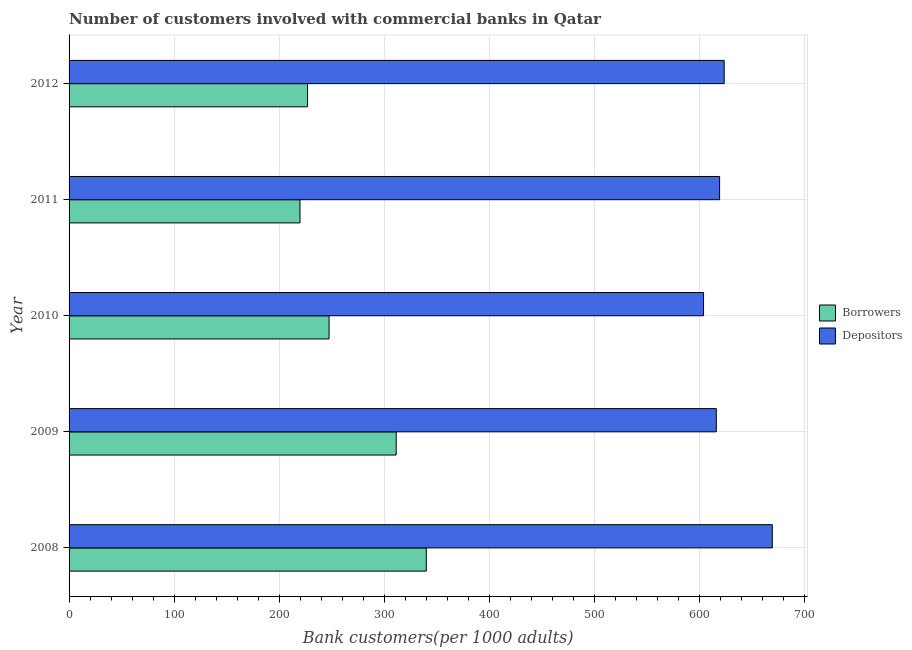Are the number of bars on each tick of the Y-axis equal?
Offer a terse response. Yes. What is the label of the 4th group of bars from the top?
Ensure brevity in your answer.  2009. What is the number of borrowers in 2009?
Ensure brevity in your answer.  311.18. Across all years, what is the maximum number of borrowers?
Your answer should be compact. 339.83. Across all years, what is the minimum number of borrowers?
Your response must be concise. 219.67. In which year was the number of borrowers maximum?
Provide a short and direct response. 2008. What is the total number of borrowers in the graph?
Ensure brevity in your answer.  1344.89. What is the difference between the number of borrowers in 2008 and that in 2012?
Offer a very short reply. 112.96. What is the difference between the number of borrowers in 2012 and the number of depositors in 2008?
Keep it short and to the point. -442.12. What is the average number of borrowers per year?
Offer a terse response. 268.98. In the year 2011, what is the difference between the number of borrowers and number of depositors?
Offer a very short reply. -399.17. In how many years, is the number of borrowers greater than 680 ?
Your answer should be compact. 0. What is the ratio of the number of borrowers in 2008 to that in 2012?
Give a very brief answer. 1.5. Is the number of depositors in 2010 less than that in 2011?
Provide a succinct answer. Yes. What is the difference between the highest and the second highest number of depositors?
Your response must be concise. 45.77. What is the difference between the highest and the lowest number of depositors?
Your answer should be very brief. 65.42. Is the sum of the number of borrowers in 2008 and 2011 greater than the maximum number of depositors across all years?
Keep it short and to the point. No. What does the 2nd bar from the top in 2010 represents?
Keep it short and to the point. Borrowers. What does the 1st bar from the bottom in 2011 represents?
Provide a short and direct response. Borrowers. How many bars are there?
Provide a short and direct response. 10. Are all the bars in the graph horizontal?
Your answer should be very brief. Yes. How many years are there in the graph?
Offer a terse response. 5. What is the difference between two consecutive major ticks on the X-axis?
Provide a short and direct response. 100. Are the values on the major ticks of X-axis written in scientific E-notation?
Your answer should be compact. No. Does the graph contain grids?
Your answer should be very brief. Yes. What is the title of the graph?
Offer a terse response. Number of customers involved with commercial banks in Qatar. Does "RDB nonconcessional" appear as one of the legend labels in the graph?
Provide a short and direct response. No. What is the label or title of the X-axis?
Your response must be concise. Bank customers(per 1000 adults). What is the Bank customers(per 1000 adults) in Borrowers in 2008?
Your response must be concise. 339.83. What is the Bank customers(per 1000 adults) of Depositors in 2008?
Ensure brevity in your answer.  668.99. What is the Bank customers(per 1000 adults) in Borrowers in 2009?
Your response must be concise. 311.18. What is the Bank customers(per 1000 adults) in Depositors in 2009?
Give a very brief answer. 615.73. What is the Bank customers(per 1000 adults) in Borrowers in 2010?
Give a very brief answer. 247.33. What is the Bank customers(per 1000 adults) in Depositors in 2010?
Your response must be concise. 603.57. What is the Bank customers(per 1000 adults) of Borrowers in 2011?
Your answer should be compact. 219.67. What is the Bank customers(per 1000 adults) in Depositors in 2011?
Provide a short and direct response. 618.84. What is the Bank customers(per 1000 adults) of Borrowers in 2012?
Your response must be concise. 226.87. What is the Bank customers(per 1000 adults) in Depositors in 2012?
Keep it short and to the point. 623.22. Across all years, what is the maximum Bank customers(per 1000 adults) of Borrowers?
Offer a very short reply. 339.83. Across all years, what is the maximum Bank customers(per 1000 adults) of Depositors?
Keep it short and to the point. 668.99. Across all years, what is the minimum Bank customers(per 1000 adults) of Borrowers?
Provide a short and direct response. 219.67. Across all years, what is the minimum Bank customers(per 1000 adults) in Depositors?
Make the answer very short. 603.57. What is the total Bank customers(per 1000 adults) in Borrowers in the graph?
Offer a very short reply. 1344.89. What is the total Bank customers(per 1000 adults) in Depositors in the graph?
Your response must be concise. 3130.35. What is the difference between the Bank customers(per 1000 adults) of Borrowers in 2008 and that in 2009?
Give a very brief answer. 28.65. What is the difference between the Bank customers(per 1000 adults) of Depositors in 2008 and that in 2009?
Keep it short and to the point. 53.27. What is the difference between the Bank customers(per 1000 adults) of Borrowers in 2008 and that in 2010?
Your answer should be compact. 92.5. What is the difference between the Bank customers(per 1000 adults) in Depositors in 2008 and that in 2010?
Offer a terse response. 65.42. What is the difference between the Bank customers(per 1000 adults) in Borrowers in 2008 and that in 2011?
Provide a short and direct response. 120.16. What is the difference between the Bank customers(per 1000 adults) of Depositors in 2008 and that in 2011?
Make the answer very short. 50.15. What is the difference between the Bank customers(per 1000 adults) of Borrowers in 2008 and that in 2012?
Offer a terse response. 112.96. What is the difference between the Bank customers(per 1000 adults) in Depositors in 2008 and that in 2012?
Your response must be concise. 45.77. What is the difference between the Bank customers(per 1000 adults) in Borrowers in 2009 and that in 2010?
Provide a short and direct response. 63.85. What is the difference between the Bank customers(per 1000 adults) of Depositors in 2009 and that in 2010?
Your answer should be compact. 12.15. What is the difference between the Bank customers(per 1000 adults) of Borrowers in 2009 and that in 2011?
Make the answer very short. 91.51. What is the difference between the Bank customers(per 1000 adults) in Depositors in 2009 and that in 2011?
Ensure brevity in your answer.  -3.12. What is the difference between the Bank customers(per 1000 adults) in Borrowers in 2009 and that in 2012?
Give a very brief answer. 84.31. What is the difference between the Bank customers(per 1000 adults) in Depositors in 2009 and that in 2012?
Ensure brevity in your answer.  -7.5. What is the difference between the Bank customers(per 1000 adults) of Borrowers in 2010 and that in 2011?
Keep it short and to the point. 27.65. What is the difference between the Bank customers(per 1000 adults) in Depositors in 2010 and that in 2011?
Ensure brevity in your answer.  -15.27. What is the difference between the Bank customers(per 1000 adults) in Borrowers in 2010 and that in 2012?
Your answer should be compact. 20.46. What is the difference between the Bank customers(per 1000 adults) of Depositors in 2010 and that in 2012?
Give a very brief answer. -19.65. What is the difference between the Bank customers(per 1000 adults) in Borrowers in 2011 and that in 2012?
Give a very brief answer. -7.2. What is the difference between the Bank customers(per 1000 adults) of Depositors in 2011 and that in 2012?
Make the answer very short. -4.38. What is the difference between the Bank customers(per 1000 adults) in Borrowers in 2008 and the Bank customers(per 1000 adults) in Depositors in 2009?
Offer a terse response. -275.9. What is the difference between the Bank customers(per 1000 adults) of Borrowers in 2008 and the Bank customers(per 1000 adults) of Depositors in 2010?
Offer a terse response. -263.74. What is the difference between the Bank customers(per 1000 adults) of Borrowers in 2008 and the Bank customers(per 1000 adults) of Depositors in 2011?
Your answer should be compact. -279.01. What is the difference between the Bank customers(per 1000 adults) in Borrowers in 2008 and the Bank customers(per 1000 adults) in Depositors in 2012?
Provide a succinct answer. -283.39. What is the difference between the Bank customers(per 1000 adults) of Borrowers in 2009 and the Bank customers(per 1000 adults) of Depositors in 2010?
Ensure brevity in your answer.  -292.39. What is the difference between the Bank customers(per 1000 adults) of Borrowers in 2009 and the Bank customers(per 1000 adults) of Depositors in 2011?
Your response must be concise. -307.66. What is the difference between the Bank customers(per 1000 adults) of Borrowers in 2009 and the Bank customers(per 1000 adults) of Depositors in 2012?
Your response must be concise. -312.04. What is the difference between the Bank customers(per 1000 adults) in Borrowers in 2010 and the Bank customers(per 1000 adults) in Depositors in 2011?
Offer a terse response. -371.51. What is the difference between the Bank customers(per 1000 adults) of Borrowers in 2010 and the Bank customers(per 1000 adults) of Depositors in 2012?
Make the answer very short. -375.89. What is the difference between the Bank customers(per 1000 adults) of Borrowers in 2011 and the Bank customers(per 1000 adults) of Depositors in 2012?
Offer a terse response. -403.55. What is the average Bank customers(per 1000 adults) in Borrowers per year?
Your answer should be very brief. 268.98. What is the average Bank customers(per 1000 adults) of Depositors per year?
Provide a succinct answer. 626.07. In the year 2008, what is the difference between the Bank customers(per 1000 adults) in Borrowers and Bank customers(per 1000 adults) in Depositors?
Ensure brevity in your answer.  -329.16. In the year 2009, what is the difference between the Bank customers(per 1000 adults) in Borrowers and Bank customers(per 1000 adults) in Depositors?
Make the answer very short. -304.54. In the year 2010, what is the difference between the Bank customers(per 1000 adults) in Borrowers and Bank customers(per 1000 adults) in Depositors?
Ensure brevity in your answer.  -356.24. In the year 2011, what is the difference between the Bank customers(per 1000 adults) of Borrowers and Bank customers(per 1000 adults) of Depositors?
Give a very brief answer. -399.17. In the year 2012, what is the difference between the Bank customers(per 1000 adults) of Borrowers and Bank customers(per 1000 adults) of Depositors?
Provide a succinct answer. -396.35. What is the ratio of the Bank customers(per 1000 adults) of Borrowers in 2008 to that in 2009?
Your answer should be very brief. 1.09. What is the ratio of the Bank customers(per 1000 adults) in Depositors in 2008 to that in 2009?
Your answer should be compact. 1.09. What is the ratio of the Bank customers(per 1000 adults) in Borrowers in 2008 to that in 2010?
Ensure brevity in your answer.  1.37. What is the ratio of the Bank customers(per 1000 adults) of Depositors in 2008 to that in 2010?
Your answer should be compact. 1.11. What is the ratio of the Bank customers(per 1000 adults) in Borrowers in 2008 to that in 2011?
Provide a short and direct response. 1.55. What is the ratio of the Bank customers(per 1000 adults) of Depositors in 2008 to that in 2011?
Offer a very short reply. 1.08. What is the ratio of the Bank customers(per 1000 adults) of Borrowers in 2008 to that in 2012?
Give a very brief answer. 1.5. What is the ratio of the Bank customers(per 1000 adults) in Depositors in 2008 to that in 2012?
Make the answer very short. 1.07. What is the ratio of the Bank customers(per 1000 adults) of Borrowers in 2009 to that in 2010?
Ensure brevity in your answer.  1.26. What is the ratio of the Bank customers(per 1000 adults) in Depositors in 2009 to that in 2010?
Make the answer very short. 1.02. What is the ratio of the Bank customers(per 1000 adults) of Borrowers in 2009 to that in 2011?
Provide a succinct answer. 1.42. What is the ratio of the Bank customers(per 1000 adults) in Depositors in 2009 to that in 2011?
Provide a short and direct response. 0.99. What is the ratio of the Bank customers(per 1000 adults) in Borrowers in 2009 to that in 2012?
Provide a short and direct response. 1.37. What is the ratio of the Bank customers(per 1000 adults) in Borrowers in 2010 to that in 2011?
Provide a short and direct response. 1.13. What is the ratio of the Bank customers(per 1000 adults) of Depositors in 2010 to that in 2011?
Give a very brief answer. 0.98. What is the ratio of the Bank customers(per 1000 adults) in Borrowers in 2010 to that in 2012?
Provide a short and direct response. 1.09. What is the ratio of the Bank customers(per 1000 adults) of Depositors in 2010 to that in 2012?
Your response must be concise. 0.97. What is the ratio of the Bank customers(per 1000 adults) in Borrowers in 2011 to that in 2012?
Offer a very short reply. 0.97. What is the difference between the highest and the second highest Bank customers(per 1000 adults) in Borrowers?
Make the answer very short. 28.65. What is the difference between the highest and the second highest Bank customers(per 1000 adults) in Depositors?
Give a very brief answer. 45.77. What is the difference between the highest and the lowest Bank customers(per 1000 adults) in Borrowers?
Make the answer very short. 120.16. What is the difference between the highest and the lowest Bank customers(per 1000 adults) in Depositors?
Your response must be concise. 65.42. 